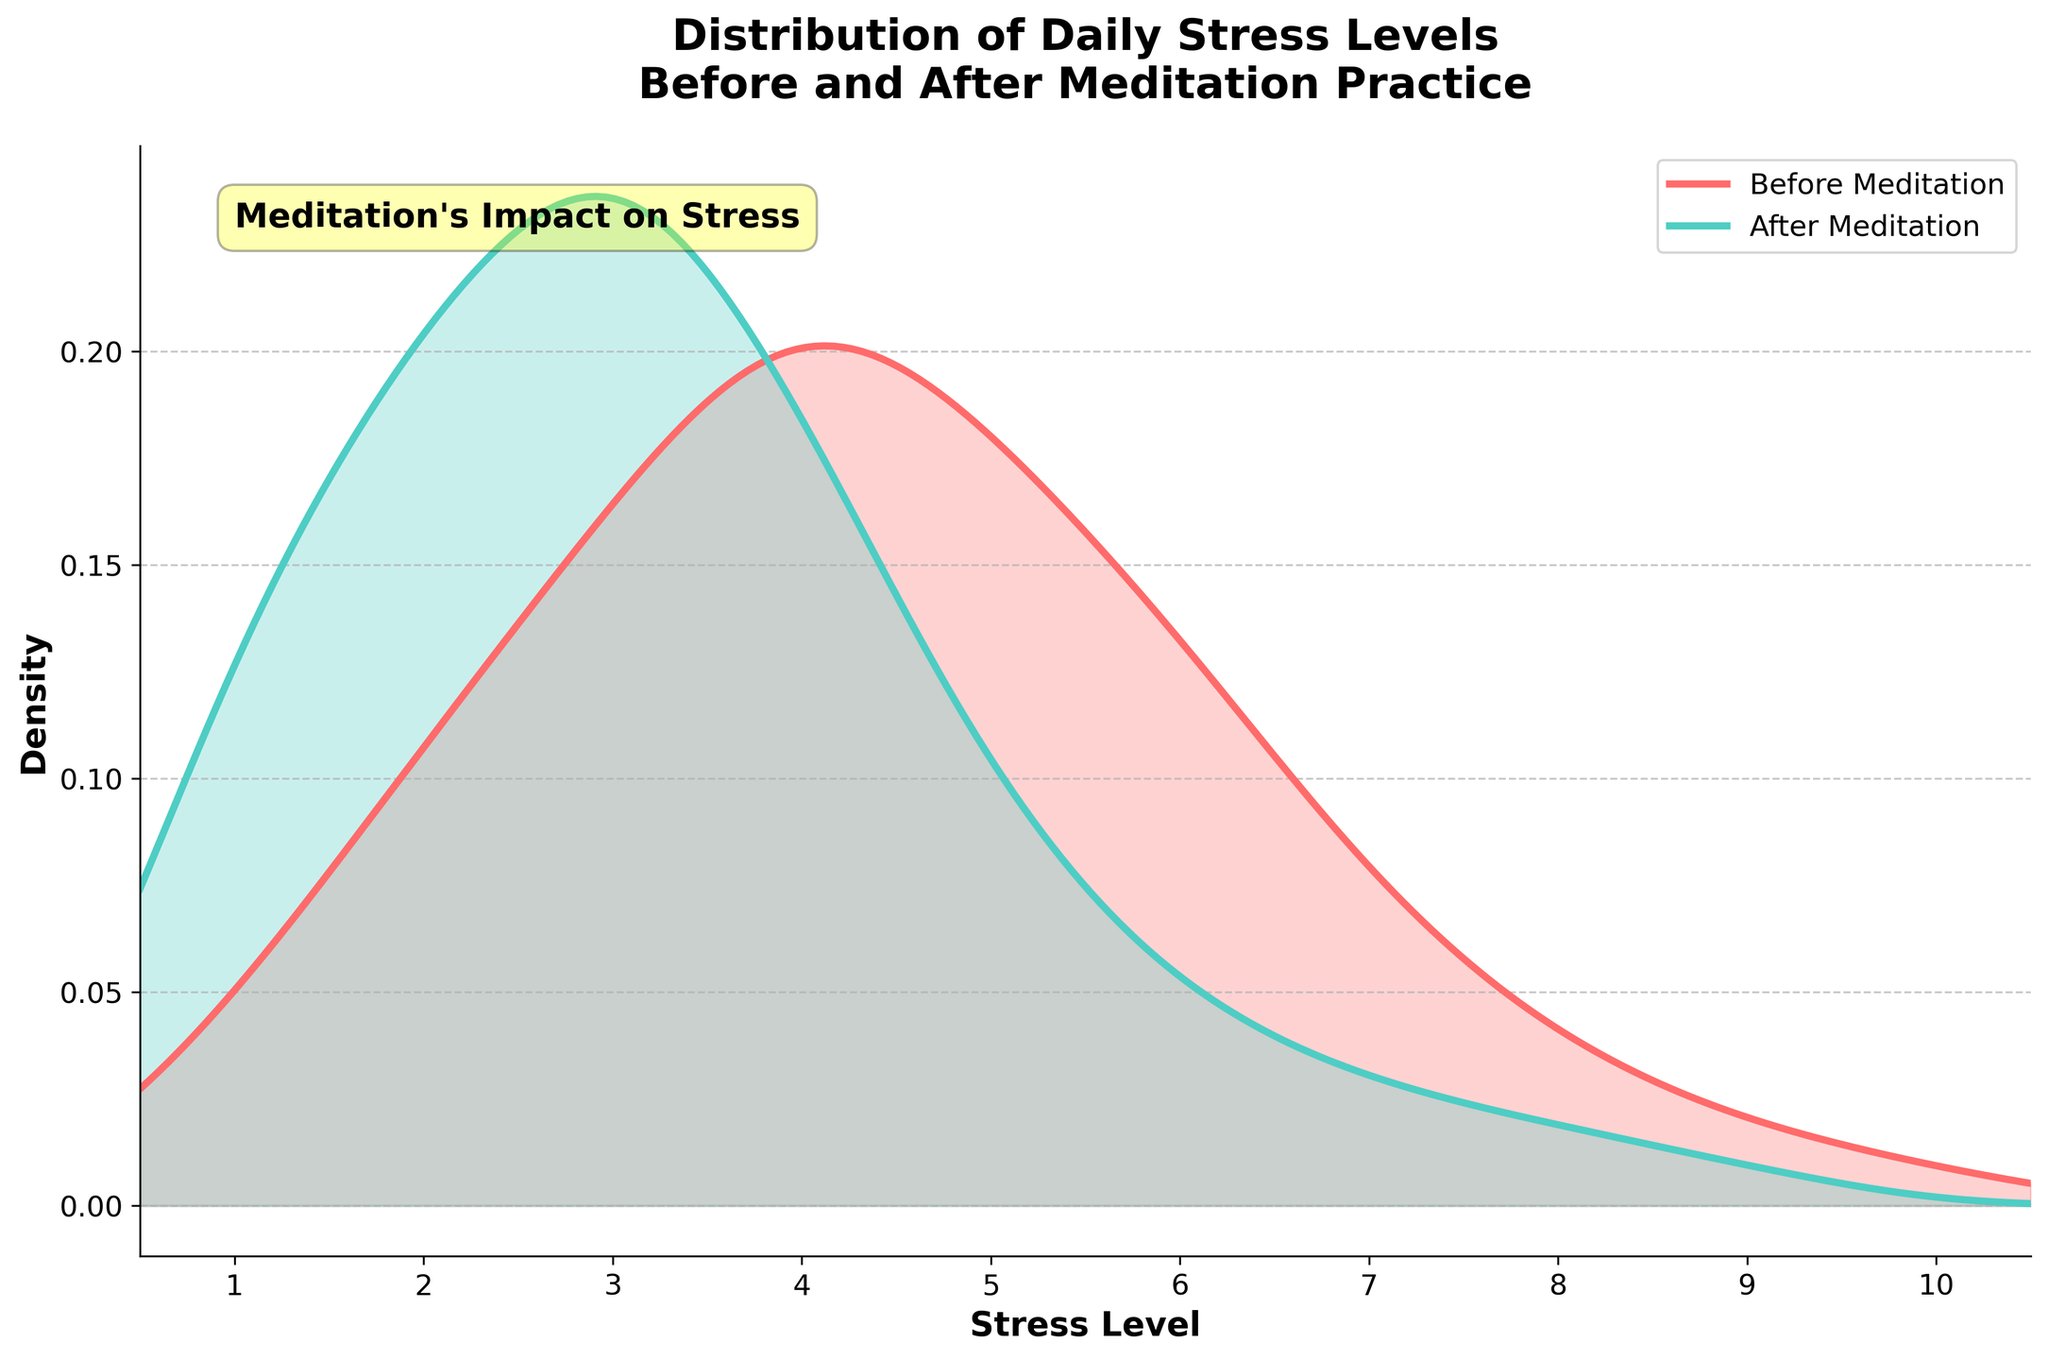What does the title of the plot indicate about the data? The title of the plot states "Distribution of Daily Stress Levels Before and After Meditation Practice". This indicates that the plot shows the distribution of stress levels among participants before they started the meditation practice and after they completed it.
Answer: Distribution of Daily Stress Levels Before and After Meditation Practice What can you tell from the colors of the curves in the plot? The plot features two curves: the red-colored curve represents stress levels before meditation practice, and the green-colored curve represents stress levels after meditation practice. This color distinction helps to visually separate and compare the two distributions.
Answer: Red: Before Meditation, Green: After Meditation Around which stress level do we see the highest density for stress levels after meditation? Examining the green-colored curve, the highest density occurs around stress level 3. The peak of the curve indicates that most participants reported a stress level of 3 after meditation.
Answer: Stress level 3 How do the peak positions of the density curves before and after meditation compare? The red-colored curve (before meditation) peaks around a stress level of 4, while the green-colored curve (after meditation) peaks around a lower stress level of 3. This indicates a reduction in stress levels post-meditation.
Answer: Before: Stress level 4, After: Stress level 3 Which period has a higher density for stress levels greater than 6? The red-colored curve (before meditation) shows a higher density for stress levels greater than 6 compared to the green-colored curve (after meditation). This implies higher stress levels were more frequent before the meditation practice.
Answer: Before Meditation By comparing the curves, what can you deduce about the effect of meditation on stress levels? The green-colored curve after meditation shows a lower peak and a shift towards lower stress levels compared to the red-colored curve before meditation. This suggests that meditation led to a significant reduction in overall stress levels for participants.
Answer: Reduction in stress levels What do the areas under the two curves indicate regarding the total number of stress level reports? The areas under both curves represent the density distribution of stress levels before and after meditation. Although the exact numbers are not provided, the shapes and peaks suggest that stress levels are more evenly spread and reduced overall after meditation.
Answer: Evenly spread and reduced stress levels after meditation Considering the annotations and additional text, what is the impact summarized by the plot? The annotation "Meditation's Impact on Stress" along with the visual information indicates that meditation practice has a positive impact by lowering stress levels, evidenced by the shift and reduction in density peaks.
Answer: Positive impact in lowering stress levels What is the labeled range of stress levels on the x-axis? The x-axis is labeled with stress levels ranging from 1 to 10, evenly spaced with ticks at each integer value. This range allows for a comprehensive view of the varying reported stress levels.
Answer: 1 to 10 